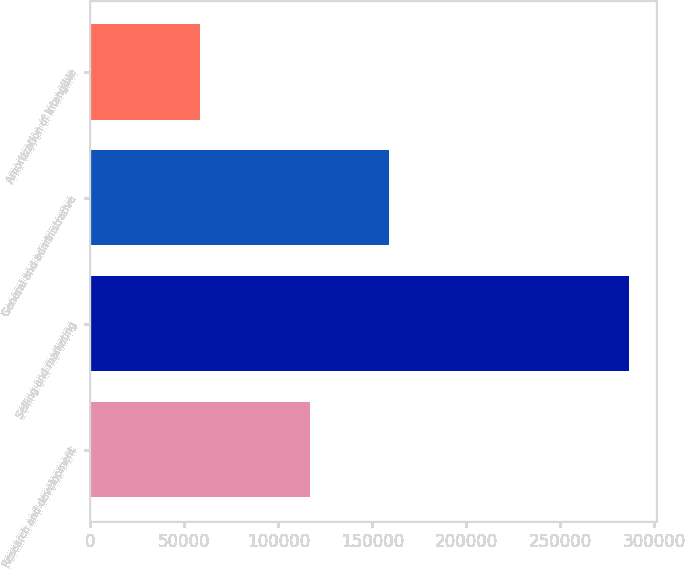Convert chart to OTSL. <chart><loc_0><loc_0><loc_500><loc_500><bar_chart><fcel>Research and development<fcel>Selling and marketing<fcel>General and administrative<fcel>Amortization of intangible<nl><fcel>116696<fcel>286730<fcel>158793<fcel>58334<nl></chart> 